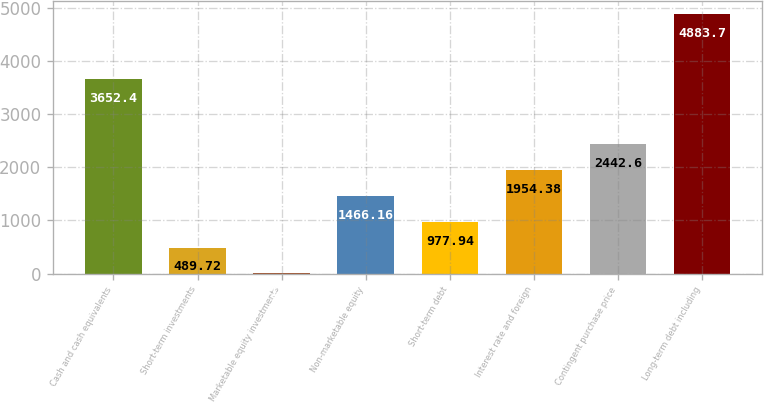<chart> <loc_0><loc_0><loc_500><loc_500><bar_chart><fcel>Cash and cash equivalents<fcel>Short-term investments<fcel>Marketable equity investments<fcel>Non-marketable equity<fcel>Short-term debt<fcel>Interest rate and foreign<fcel>Contingent purchase price<fcel>Long-term debt including<nl><fcel>3652.4<fcel>489.72<fcel>1.5<fcel>1466.16<fcel>977.94<fcel>1954.38<fcel>2442.6<fcel>4883.7<nl></chart> 